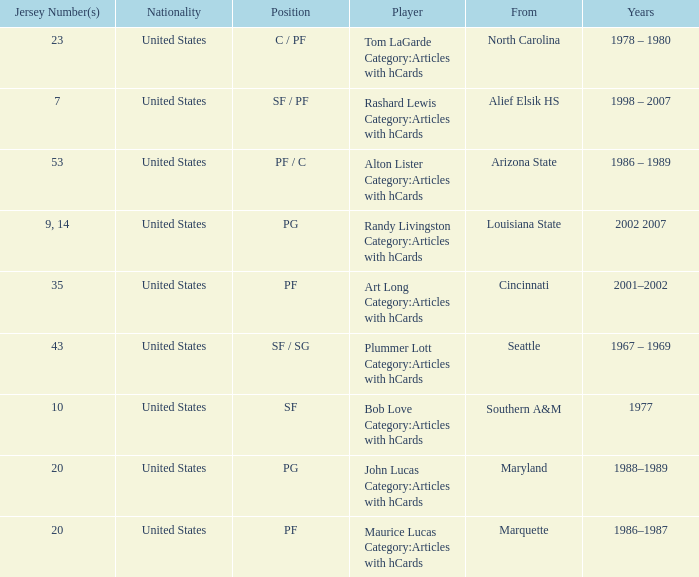Bob Love Category:Articles with hCards is from where? Southern A&M. 